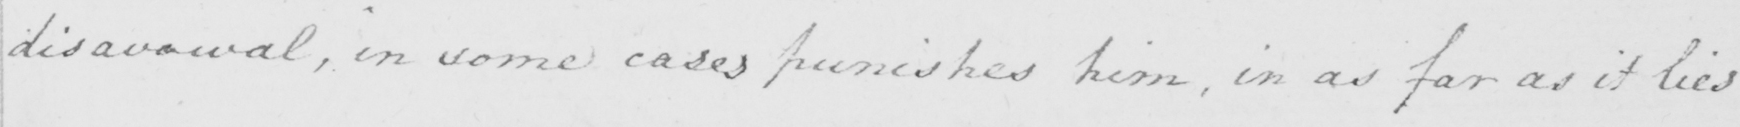What does this handwritten line say? disavowal , in some cases punishes him , in as far as it lies 